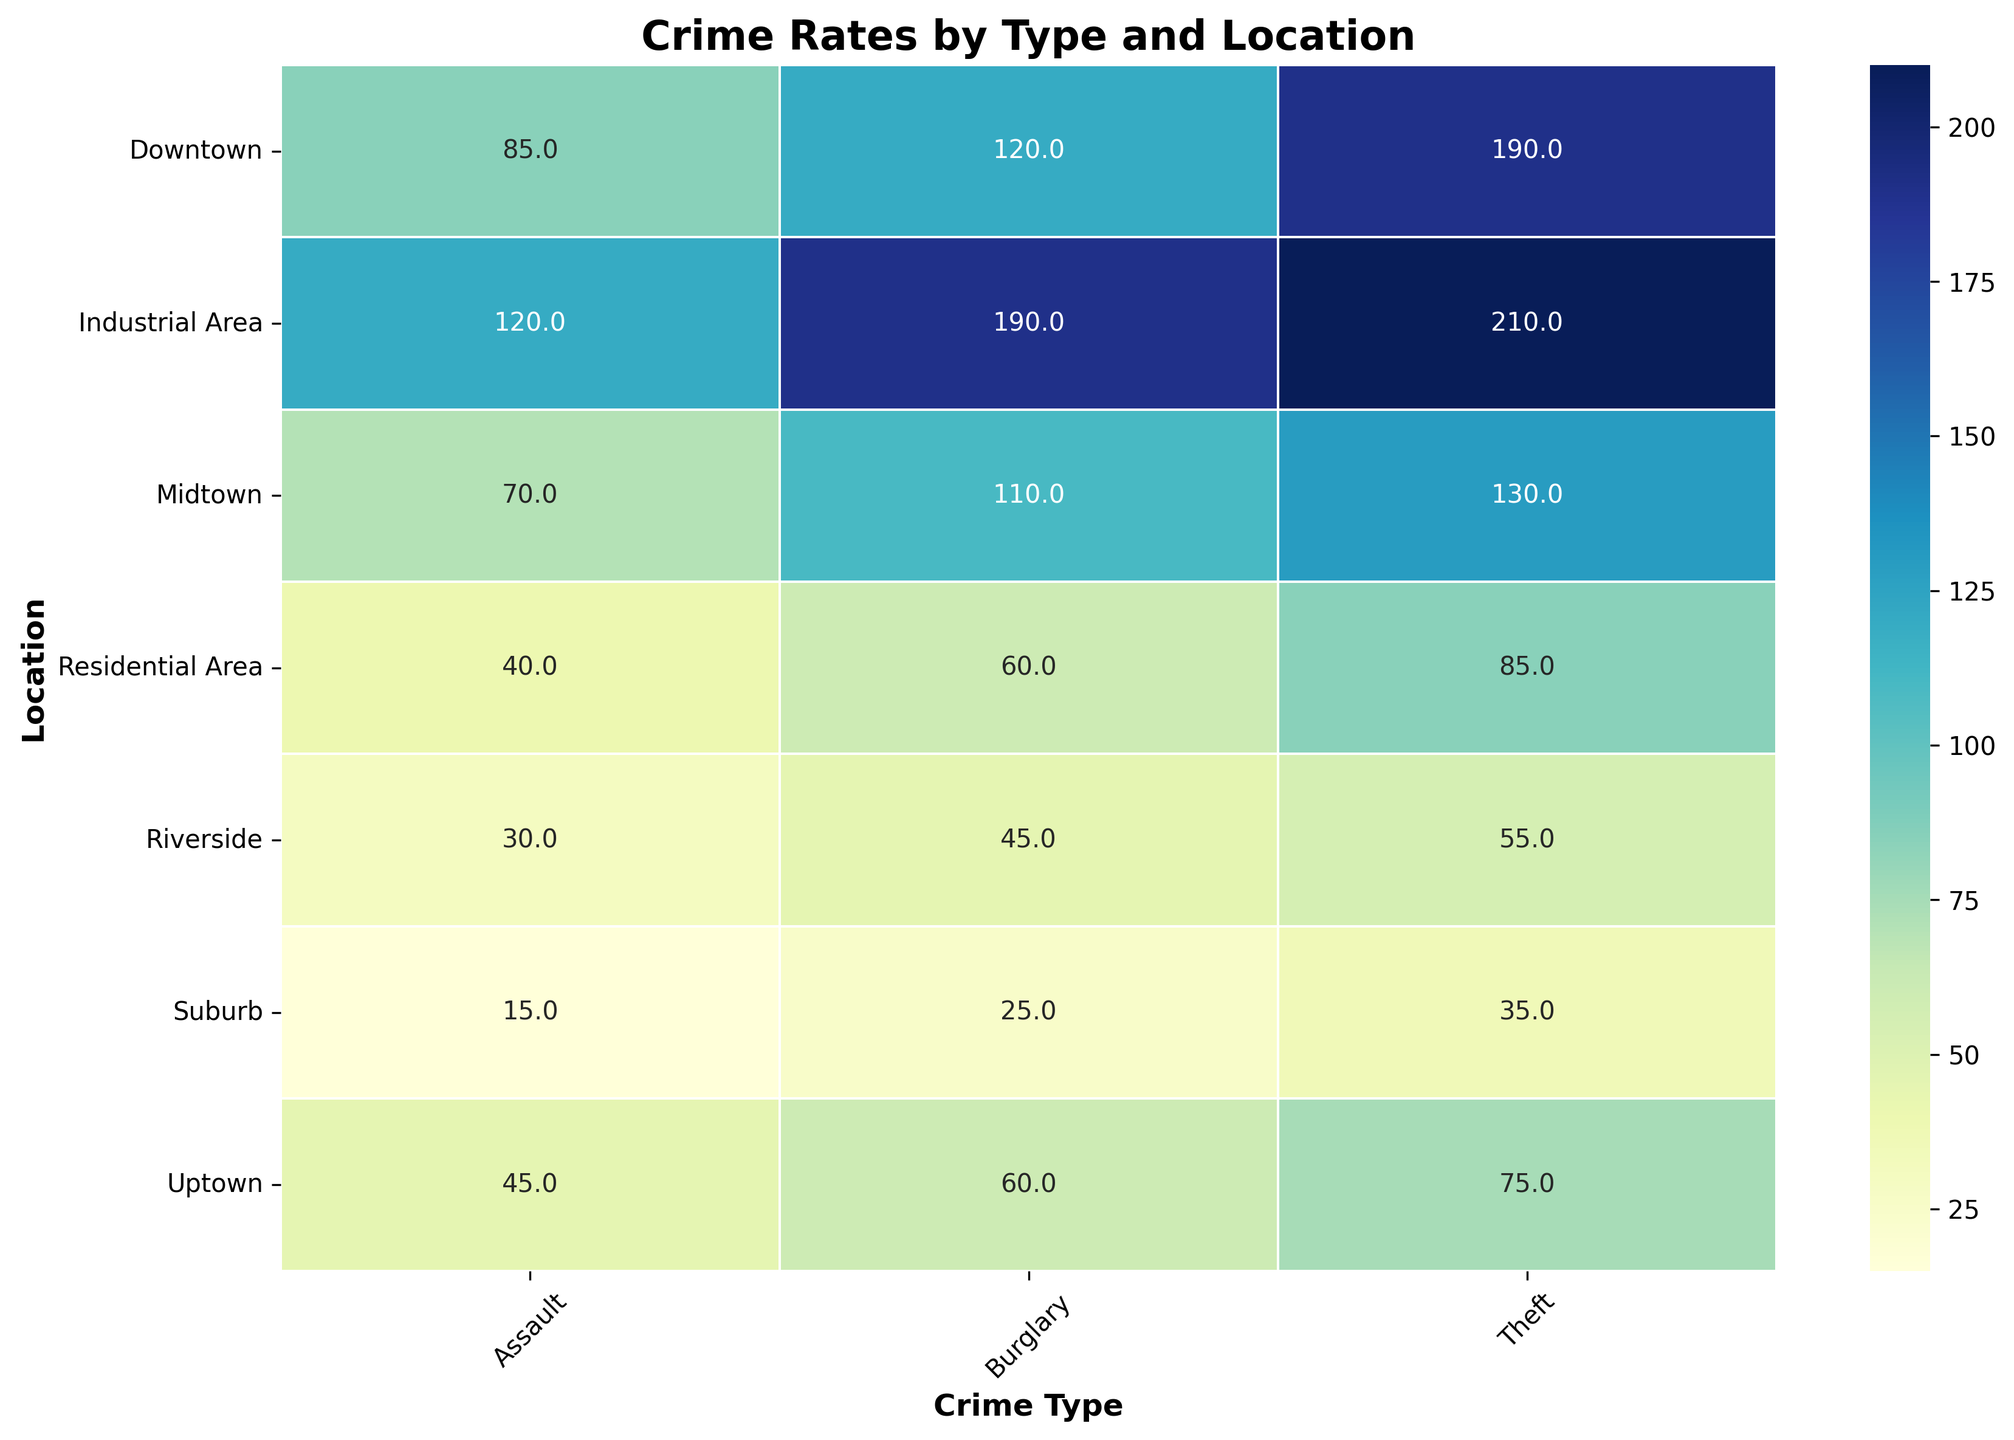What's the total crime rate for the Industrial Area? Sum the three crime rates (Burglary, Assault, Theft) in the Industrial Area, which are 190, 120, and 210. Total crime rate = 190 + 120 + 210.
Answer: 520 Which location has the highest burglary rate? Identify the location with the highest value in the Burglary column. The highest rate is 190 in the Industrial Area.
Answer: Industrial Area Between Downtown and Uptown, which location has the higher total crime rate across all crime types? Sum the crime rates (Burglary, Assault, Theft) for Downtown and Uptown. Downtown: 120 + 85 + 190 = 395, Uptown: 60 + 45 + 75 = 180. Downtown has a higher total.
Answer: Downtown Which crime type generally has the highest rates across all locations? Compare the crime rates for Burglary, Assault, and Theft across all locations to find which one has the highest values most consistently. Theft generally has the highest rates.
Answer: Theft What is the average theft rate in areas with medium policing presence? Locate the theft rates for Uptown, Riverside, and Residential Area, which all have medium policing presence. Theft rates: 75, 55, and 85. Average = (75 + 55 + 85) / 3.
Answer: 71.7 Is there any location where the assault rate equals the burglary rate? Check if there is any location where the Assault rate and Burglary rate are the same. There is no such location.
Answer: No How does the crime rate of the Riverside compare to Midtown for Theft? Compare the theft rates for Riverside and Midtown. Riverside has 55 and Midtown has 130. Midtown has a higher theft rate.
Answer: Midtown Which location shows the highest community safety initiatives, and how does its total crime rate compare to the lowest safety initiatives location? Downtown has the highest community safety initiatives (5), and Industrial Area has the lowest (1). Sum the total crime rates: Downtown: 120+85+190=395, Industrial Area: 190+120+210=520.
Answer: Downtown: 395, Industrial Area: 520 What is the difference in burglary rates between the Suburb and Midtown? Suburb burglary rate is 25 and Midtown burglary rate is 110. Difference = 110 - 25.
Answer: 85 